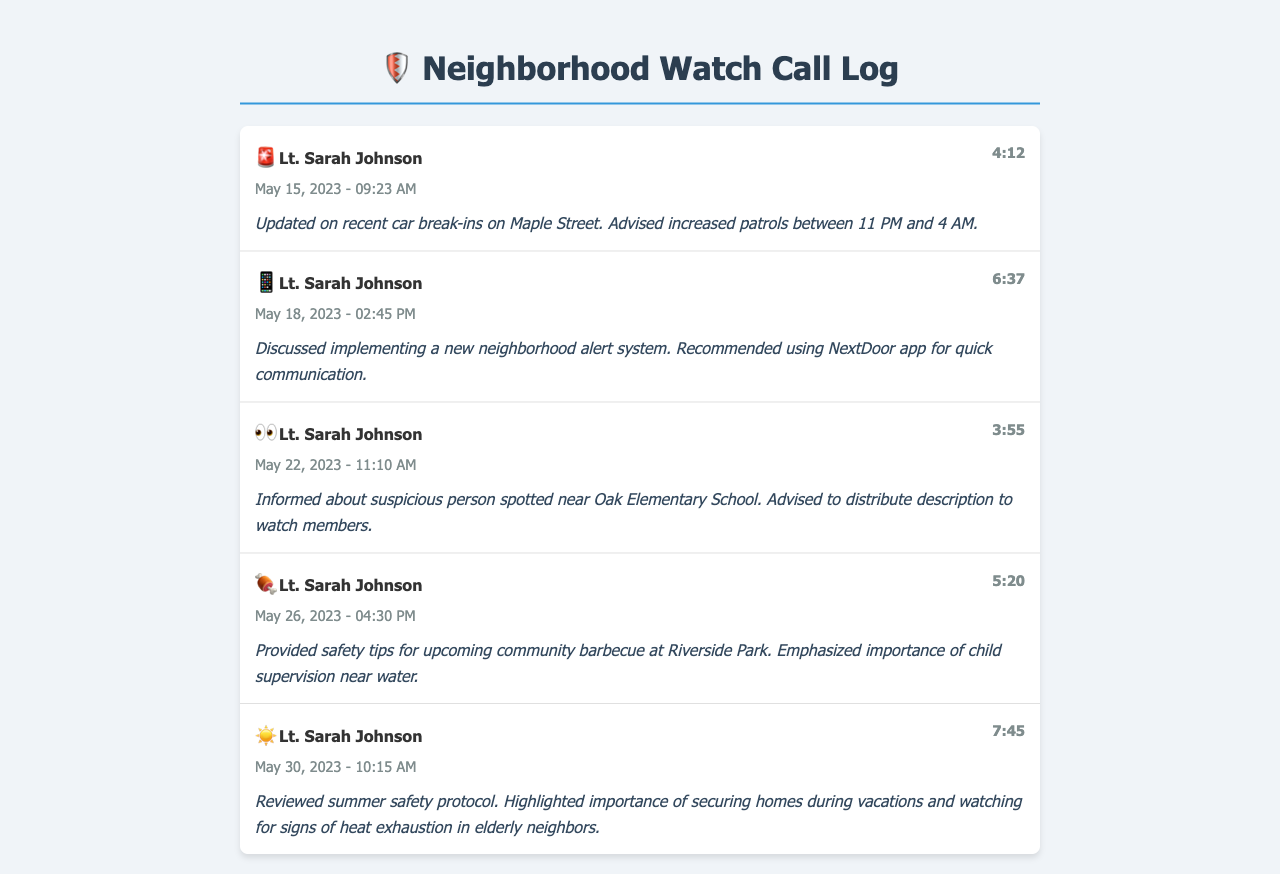What is the name of the lieutenant? The name of the lieutenant is mentioned as "Lt. Sarah Johnson" in all call entries.
Answer: Lt. Sarah Johnson How many calls were logged in total? There are five distinct call entries in the document, indicating the number of logs recorded.
Answer: 5 What is the duration of the longest call? The longest call is recorded with a duration of "7:45".
Answer: 7:45 On what date was the safety protocol for summer reviewed? The review of summer safety protocol was noted on "May 30, 2023".
Answer: May 30, 2023 What safety advice was given for the community barbecue? The advice emphasized the importance of child supervision near water during the barbecue.
Answer: Child supervision near water What suspicious activity was reported near Oak Elementary School? A suspicious person was spotted near Oak Elementary School, as reported in one of the calls.
Answer: Suspicious person What app was recommended for neighborhood communication? The document mentions that the "NextDoor app" was recommended for quick communication.
Answer: NextDoor app What was the main topic of the call on May 26, 2023? The call on May 26, 2023, primarily focused on providing safety tips for the community barbecue.
Answer: Safety tips for community barbecue What was advised to do regarding car break-ins? Increased patrols were advised between 11 PM and 4 AM in relation to car break-ins.
Answer: Increased patrols between 11 PM and 4 AM 